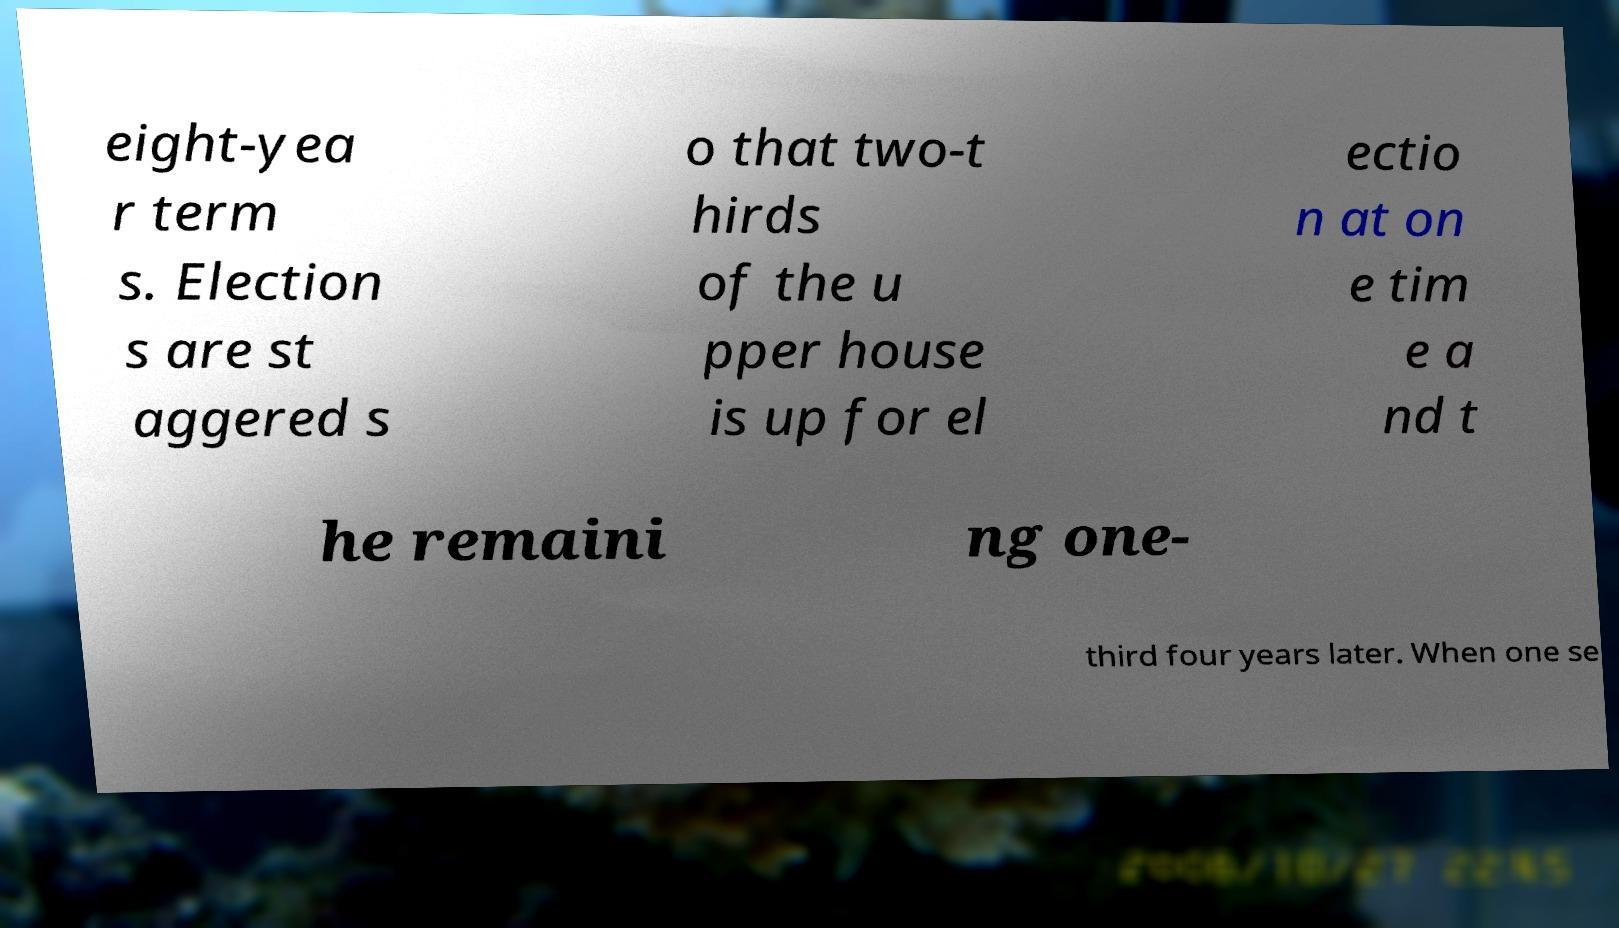For documentation purposes, I need the text within this image transcribed. Could you provide that? eight-yea r term s. Election s are st aggered s o that two-t hirds of the u pper house is up for el ectio n at on e tim e a nd t he remaini ng one- third four years later. When one se 